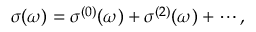<formula> <loc_0><loc_0><loc_500><loc_500>\begin{array} { r } { \sigma ( \omega ) = \sigma ^ { ( 0 ) } ( \omega ) + \sigma ^ { ( 2 ) } ( \omega ) + \cdots , } \end{array}</formula> 